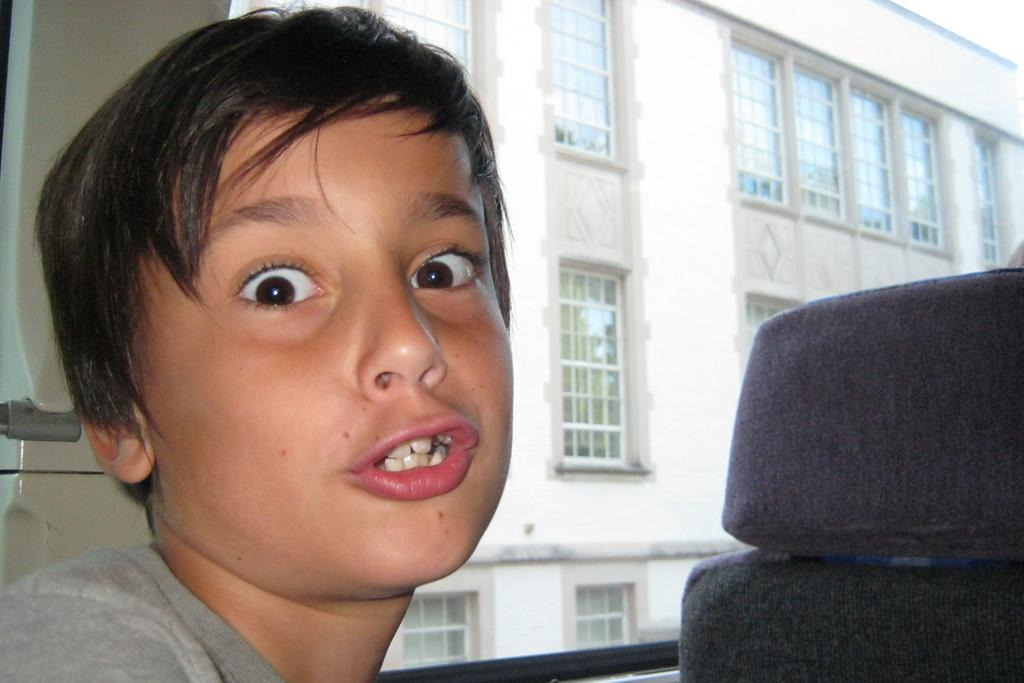What is located on the left side of the image? There is a boy on the left side of the image. What can be seen on the right side of the image? There is a seat on the right side of the image. What is visible in the background of the image? There is a building in the background of the image. What type of eggnog can be seen in the hands of the boy in the image? There is no eggnog present in the image; the boy is not holding anything. What songs are being sung by the crowd in the image? There is no crowd present in the image, so it is not possible to determine what songs might be sung. 